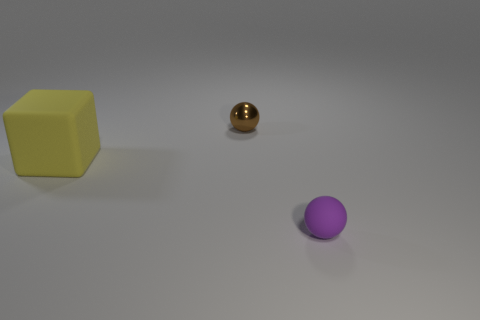Add 2 tiny brown metal spheres. How many objects exist? 5 Subtract all cubes. How many objects are left? 2 Add 1 small balls. How many small balls exist? 3 Subtract 0 purple cylinders. How many objects are left? 3 Subtract all purple matte spheres. Subtract all purple balls. How many objects are left? 1 Add 3 brown metallic balls. How many brown metallic balls are left? 4 